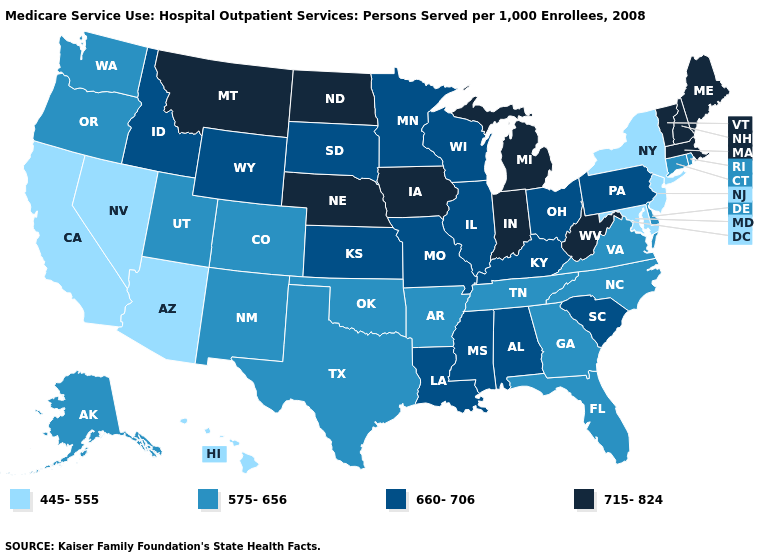Does Kansas have the highest value in the USA?
Give a very brief answer. No. Name the states that have a value in the range 575-656?
Write a very short answer. Alaska, Arkansas, Colorado, Connecticut, Delaware, Florida, Georgia, New Mexico, North Carolina, Oklahoma, Oregon, Rhode Island, Tennessee, Texas, Utah, Virginia, Washington. Does West Virginia have the highest value in the South?
Write a very short answer. Yes. What is the value of Utah?
Short answer required. 575-656. What is the value of Vermont?
Short answer required. 715-824. Among the states that border Washington , which have the highest value?
Quick response, please. Idaho. What is the value of Wisconsin?
Short answer required. 660-706. What is the lowest value in states that border West Virginia?
Give a very brief answer. 445-555. Name the states that have a value in the range 660-706?
Quick response, please. Alabama, Idaho, Illinois, Kansas, Kentucky, Louisiana, Minnesota, Mississippi, Missouri, Ohio, Pennsylvania, South Carolina, South Dakota, Wisconsin, Wyoming. Among the states that border Vermont , which have the lowest value?
Quick response, please. New York. Which states have the lowest value in the West?
Answer briefly. Arizona, California, Hawaii, Nevada. Name the states that have a value in the range 715-824?
Short answer required. Indiana, Iowa, Maine, Massachusetts, Michigan, Montana, Nebraska, New Hampshire, North Dakota, Vermont, West Virginia. Among the states that border Missouri , which have the lowest value?
Keep it brief. Arkansas, Oklahoma, Tennessee. What is the value of Illinois?
Concise answer only. 660-706. Does Washington have a lower value than Arkansas?
Quick response, please. No. 